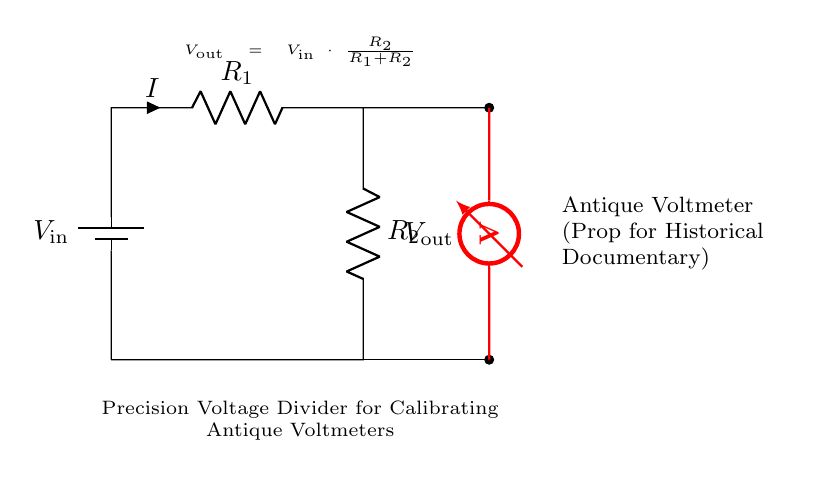What is the input voltage of the circuit? The input voltage, denoted as V_in, is the voltage applied to the circuit from the battery, which is the first component shown in the diagram.
Answer: V_in What are the resistance values used in the voltage divider? The resistances of R1 and R2 are key components in determining the output voltage. However, the circuit does not specify their values, so the answer would be based on the typical values used in such applications if not indicated.
Answer: Not specified What is the output voltage formula shown in the circuit? The formula for the output voltage V_out is presented in the circuit diagram. It expresses V_out as V_in multiplied by the ratio of R2 to the total resistance (R1 + R2).
Answer: V_out = V_in * (R2 / (R1 + R2)) Identify the purpose of this circuit. The circuit's primary purpose is indicated by the labeling, which specifies it as a precision voltage divider aimed at calibrating antique voltmeters used as props.
Answer: Calibration of antique voltmeters What component measures the output voltage in this circuit? The component responsible for measuring the output voltage between the two resistor connections is labeled in red as a voltmeter, signifying its role in the circuit.
Answer: Voltmeter Why is a voltage divider used for antique voltmeters? A voltage divider is utilized because it allows for precise adjustment of voltages, which is crucial for calibrating voltmeters to ensure they provide accurate readings, especially for historical accuracy in documentaries.
Answer: To ensure accurate voltage readings 